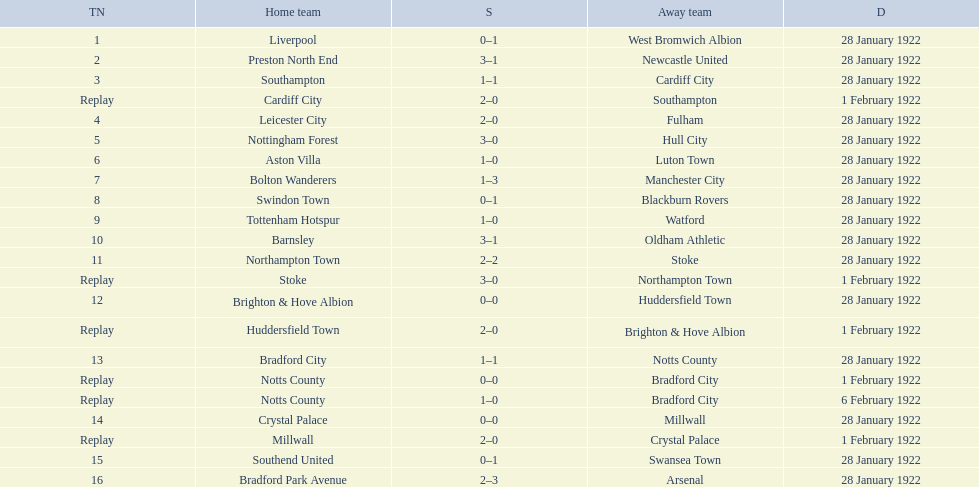Which game had a higher total number of goals scored, 1 or 16? 16. 